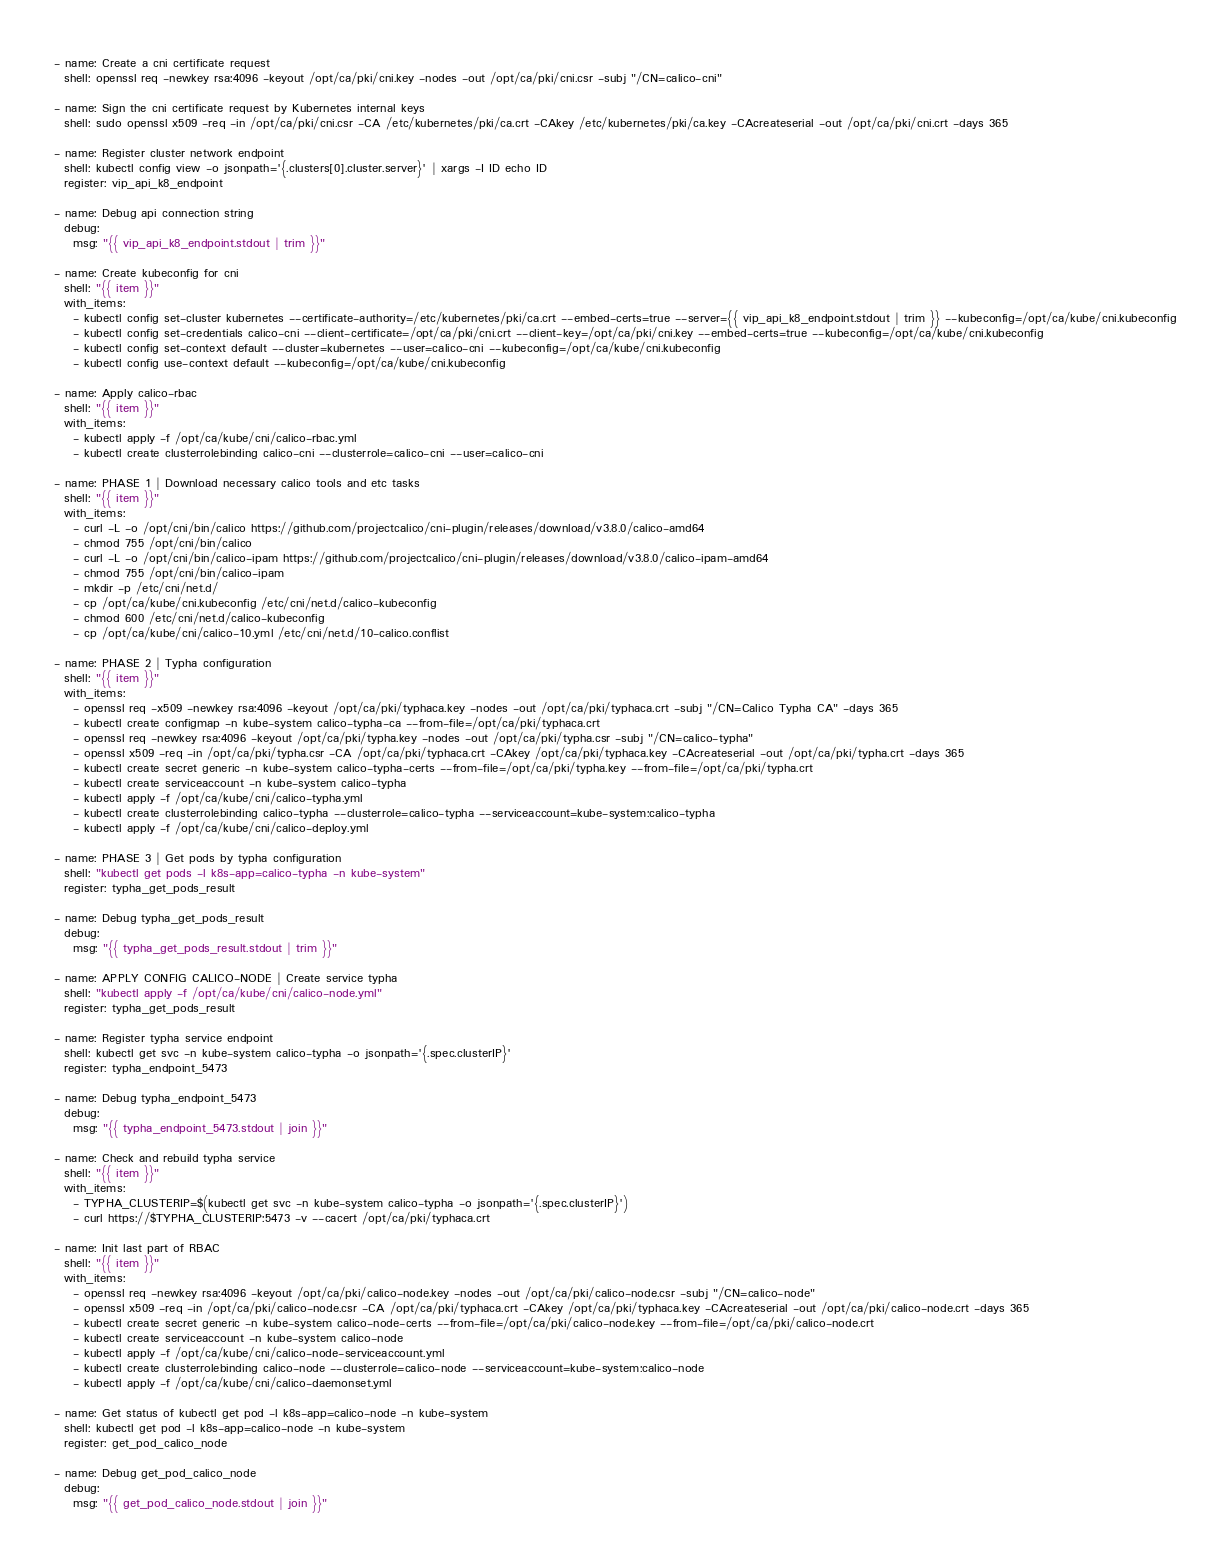<code> <loc_0><loc_0><loc_500><loc_500><_YAML_>- name: Create a cni certificate request
  shell: openssl req -newkey rsa:4096 -keyout /opt/ca/pki/cni.key -nodes -out /opt/ca/pki/cni.csr -subj "/CN=calico-cni"

- name: Sign the cni certificate request by Kubernetes internal keys
  shell: sudo openssl x509 -req -in /opt/ca/pki/cni.csr -CA /etc/kubernetes/pki/ca.crt -CAkey /etc/kubernetes/pki/ca.key -CAcreateserial -out /opt/ca/pki/cni.crt -days 365

- name: Register cluster network endpoint
  shell: kubectl config view -o jsonpath='{.clusters[0].cluster.server}' | xargs -I ID echo ID
  register: vip_api_k8_endpoint

- name: Debug api connection string
  debug:
    msg: "{{ vip_api_k8_endpoint.stdout | trim }}"

- name: Create kubeconfig for cni
  shell: "{{ item }}"
  with_items:
    - kubectl config set-cluster kubernetes --certificate-authority=/etc/kubernetes/pki/ca.crt --embed-certs=true --server={{ vip_api_k8_endpoint.stdout | trim }} --kubeconfig=/opt/ca/kube/cni.kubeconfig
    - kubectl config set-credentials calico-cni --client-certificate=/opt/ca/pki/cni.crt --client-key=/opt/ca/pki/cni.key --embed-certs=true --kubeconfig=/opt/ca/kube/cni.kubeconfig
    - kubectl config set-context default --cluster=kubernetes --user=calico-cni --kubeconfig=/opt/ca/kube/cni.kubeconfig
    - kubectl config use-context default --kubeconfig=/opt/ca/kube/cni.kubeconfig

- name: Apply calico-rbac
  shell: "{{ item }}"
  with_items:
    - kubectl apply -f /opt/ca/kube/cni/calico-rbac.yml
    - kubectl create clusterrolebinding calico-cni --clusterrole=calico-cni --user=calico-cni

- name: PHASE 1 | Download necessary calico tools and etc tasks
  shell: "{{ item }}"
  with_items:
    - curl -L -o /opt/cni/bin/calico https://github.com/projectcalico/cni-plugin/releases/download/v3.8.0/calico-amd64
    - chmod 755 /opt/cni/bin/calico
    - curl -L -o /opt/cni/bin/calico-ipam https://github.com/projectcalico/cni-plugin/releases/download/v3.8.0/calico-ipam-amd64
    - chmod 755 /opt/cni/bin/calico-ipam
    - mkdir -p /etc/cni/net.d/
    - cp /opt/ca/kube/cni.kubeconfig /etc/cni/net.d/calico-kubeconfig
    - chmod 600 /etc/cni/net.d/calico-kubeconfig
    - cp /opt/ca/kube/cni/calico-10.yml /etc/cni/net.d/10-calico.conflist

- name: PHASE 2 | Typha configuration
  shell: "{{ item }}"
  with_items:
    - openssl req -x509 -newkey rsa:4096 -keyout /opt/ca/pki/typhaca.key -nodes -out /opt/ca/pki/typhaca.crt -subj "/CN=Calico Typha CA" -days 365
    - kubectl create configmap -n kube-system calico-typha-ca --from-file=/opt/ca/pki/typhaca.crt
    - openssl req -newkey rsa:4096 -keyout /opt/ca/pki/typha.key -nodes -out /opt/ca/pki/typha.csr -subj "/CN=calico-typha"
    - openssl x509 -req -in /opt/ca/pki/typha.csr -CA /opt/ca/pki/typhaca.crt -CAkey /opt/ca/pki/typhaca.key -CAcreateserial -out /opt/ca/pki/typha.crt -days 365
    - kubectl create secret generic -n kube-system calico-typha-certs --from-file=/opt/ca/pki/typha.key --from-file=/opt/ca/pki/typha.crt
    - kubectl create serviceaccount -n kube-system calico-typha
    - kubectl apply -f /opt/ca/kube/cni/calico-typha.yml
    - kubectl create clusterrolebinding calico-typha --clusterrole=calico-typha --serviceaccount=kube-system:calico-typha
    - kubectl apply -f /opt/ca/kube/cni/calico-deploy.yml

- name: PHASE 3 | Get pods by typha configuration
  shell: "kubectl get pods -l k8s-app=calico-typha -n kube-system"
  register: typha_get_pods_result

- name: Debug typha_get_pods_result
  debug:
    msg: "{{ typha_get_pods_result.stdout | trim }}"

- name: APPLY CONFIG CALICO-NODE | Create service typha
  shell: "kubectl apply -f /opt/ca/kube/cni/calico-node.yml"
  register: typha_get_pods_result

- name: Register typha service endpoint
  shell: kubectl get svc -n kube-system calico-typha -o jsonpath='{.spec.clusterIP}'
  register: typha_endpoint_5473

- name: Debug typha_endpoint_5473
  debug:
    msg: "{{ typha_endpoint_5473.stdout | join }}"

- name: Check and rebuild typha service
  shell: "{{ item }}"
  with_items:
    - TYPHA_CLUSTERIP=$(kubectl get svc -n kube-system calico-typha -o jsonpath='{.spec.clusterIP}')
    - curl https://$TYPHA_CLUSTERIP:5473 -v --cacert /opt/ca/pki/typhaca.crt

- name: Init last part of RBAC
  shell: "{{ item }}"
  with_items:
    - openssl req -newkey rsa:4096 -keyout /opt/ca/pki/calico-node.key -nodes -out /opt/ca/pki/calico-node.csr -subj "/CN=calico-node"
    - openssl x509 -req -in /opt/ca/pki/calico-node.csr -CA /opt/ca/pki/typhaca.crt -CAkey /opt/ca/pki/typhaca.key -CAcreateserial -out /opt/ca/pki/calico-node.crt -days 365
    - kubectl create secret generic -n kube-system calico-node-certs --from-file=/opt/ca/pki/calico-node.key --from-file=/opt/ca/pki/calico-node.crt
    - kubectl create serviceaccount -n kube-system calico-node
    - kubectl apply -f /opt/ca/kube/cni/calico-node-serviceaccount.yml
    - kubectl create clusterrolebinding calico-node --clusterrole=calico-node --serviceaccount=kube-system:calico-node
    - kubectl apply -f /opt/ca/kube/cni/calico-daemonset.yml

- name: Get status of kubectl get pod -l k8s-app=calico-node -n kube-system
  shell: kubectl get pod -l k8s-app=calico-node -n kube-system
  register: get_pod_calico_node

- name: Debug get_pod_calico_node
  debug:
    msg: "{{ get_pod_calico_node.stdout | join }}"
</code> 